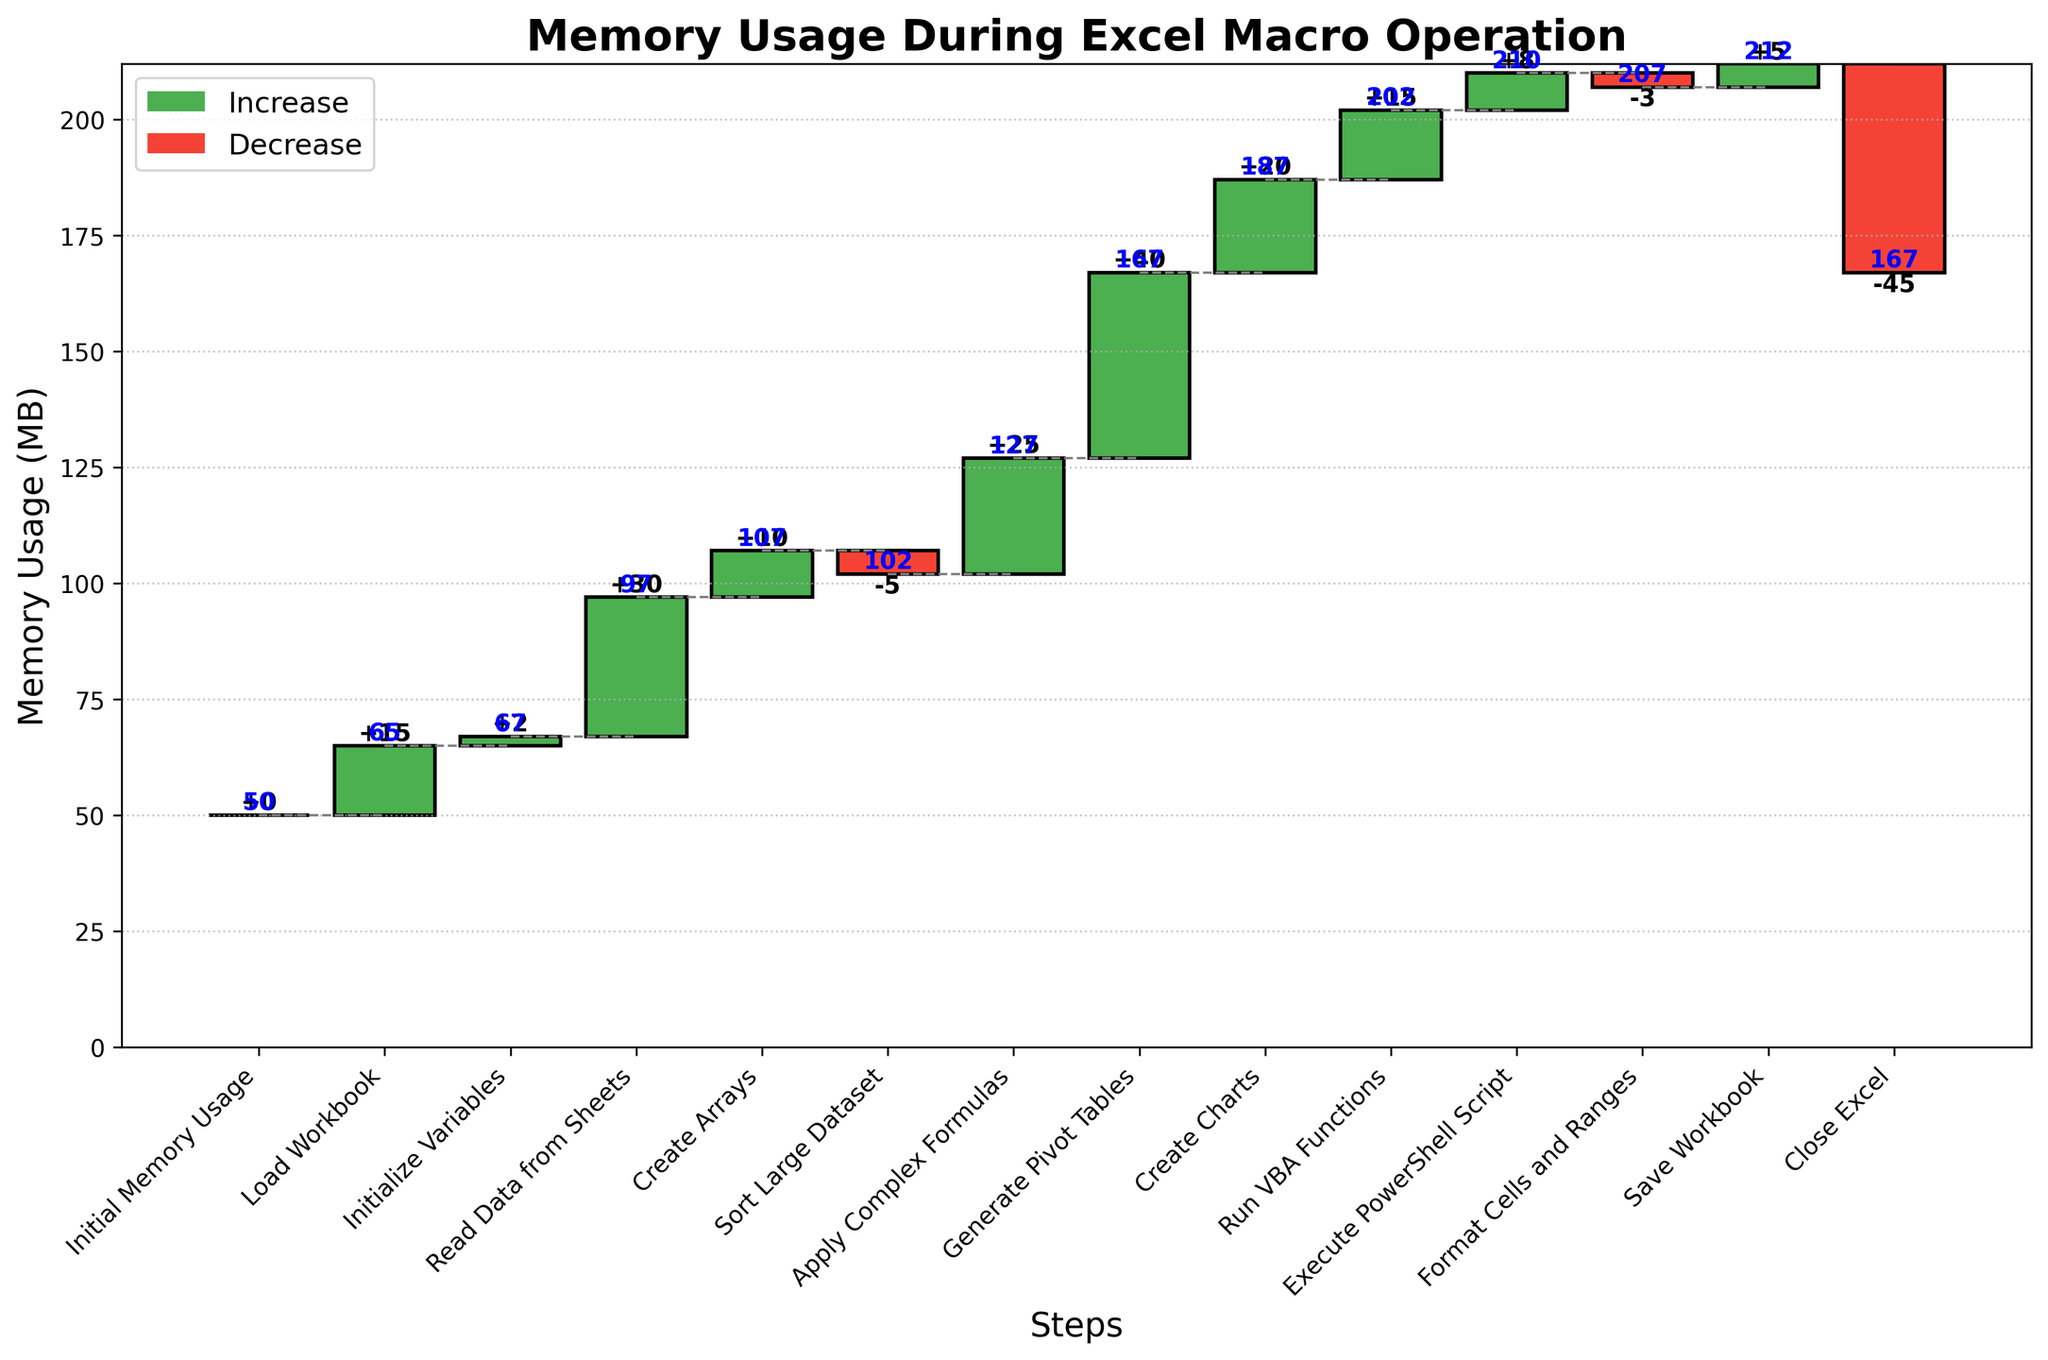What is the title of the chart? The title is given at the top of the chart and describes the content of the chart. The title can typically be found easily by looking at the chart.
Answer: Memory Usage During Excel Macro Operation How many steps are displayed in the chart? Count the number of bars in the chart, each representing a step.
Answer: 14 What is the initial memory usage? The initial memory usage is shown as the first entry in the running total at the "Initial Memory Usage" step.
Answer: 50 MB Which step shows the highest increase in memory usage and by how much? Look for the bar with the greatest positive value. This corresponds to "Generate Pivot Tables" with a memory increase of 40 MB.
Answer: Generate Pivot Tables, 40 MB Which steps result in a decrease in memory usage? Identify the bars with negative values and list the corresponding step names. These are "Sort Large Dataset," "Format Cells and Ranges," and "Close Excel."
Answer: Sort Large Dataset, Format Cells and Ranges, Close Excel What is the final memory usage after all steps have been completed? Look at the last value in the running total column, which is at the "Close Excel" step.
Answer: 167 MB What's the total memory increase during the "Apply Complex Formulas" and "Generate Pivot Tables" steps? Sum the memory changes for these two steps (25 MB for Apply Complex Formulas and 40 MB for Generate Pivot Tables).
Answer: 65 MB Compare the memory changes between loading the workbook and saving the workbook. Which one has a higher change? The memory change for loading the workbook is 15 MB, and for saving the workbook is 5 MB. Compare these two numbers.
Answer: Loading the workbook has a higher change What is the overall net change in memory from the initial to the final step? Subtract the initial memory usage from the final memory usage (167 MB - 50 MB).
Answer: 117 MB How does the memory usage change after running VBA functions? Identify the memory change associated with the "Run VBA Functions" step.
Answer: 15 MB 